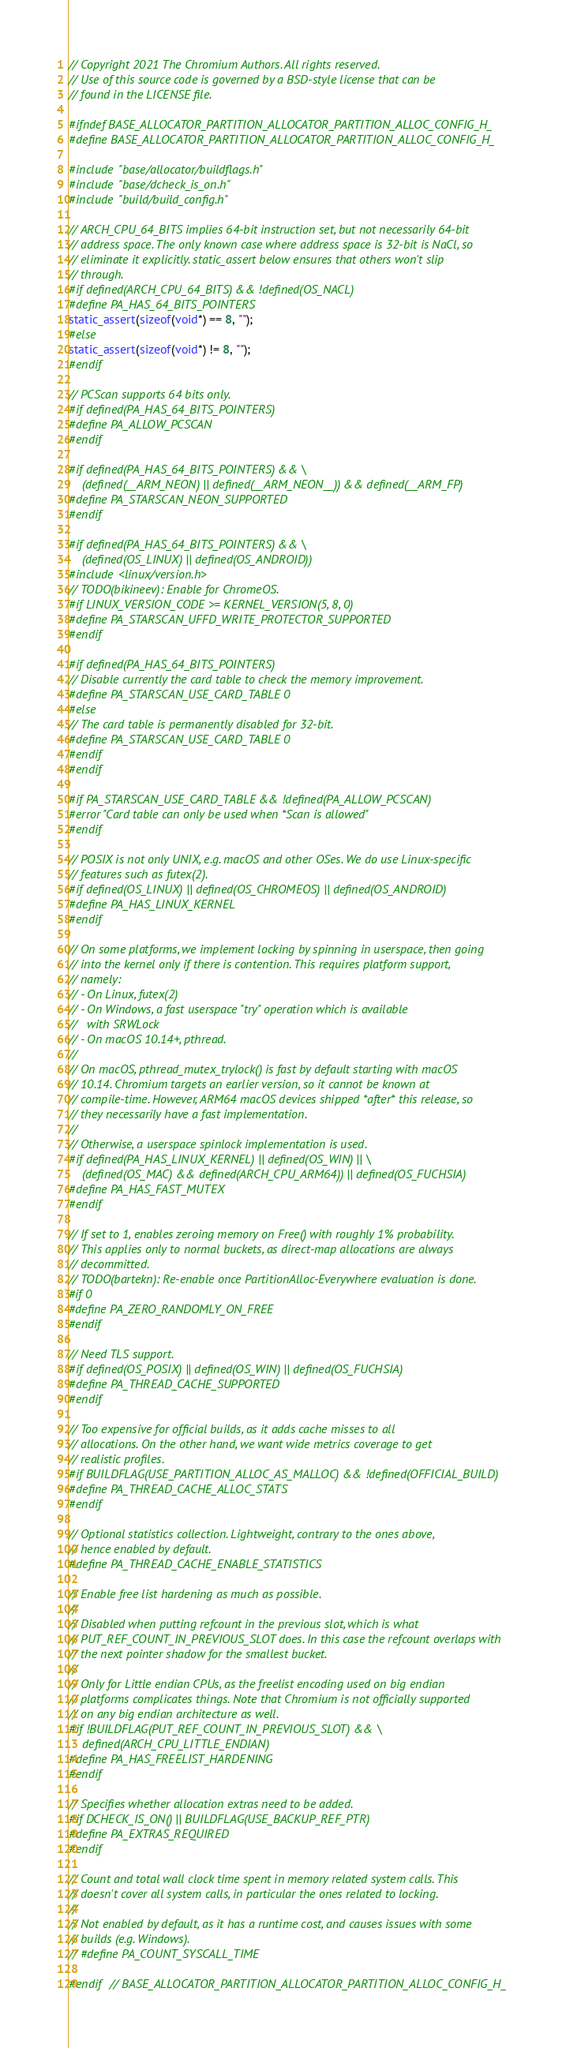<code> <loc_0><loc_0><loc_500><loc_500><_C_>// Copyright 2021 The Chromium Authors. All rights reserved.
// Use of this source code is governed by a BSD-style license that can be
// found in the LICENSE file.

#ifndef BASE_ALLOCATOR_PARTITION_ALLOCATOR_PARTITION_ALLOC_CONFIG_H_
#define BASE_ALLOCATOR_PARTITION_ALLOCATOR_PARTITION_ALLOC_CONFIG_H_

#include "base/allocator/buildflags.h"
#include "base/dcheck_is_on.h"
#include "build/build_config.h"

// ARCH_CPU_64_BITS implies 64-bit instruction set, but not necessarily 64-bit
// address space. The only known case where address space is 32-bit is NaCl, so
// eliminate it explicitly. static_assert below ensures that others won't slip
// through.
#if defined(ARCH_CPU_64_BITS) && !defined(OS_NACL)
#define PA_HAS_64_BITS_POINTERS
static_assert(sizeof(void*) == 8, "");
#else
static_assert(sizeof(void*) != 8, "");
#endif

// PCScan supports 64 bits only.
#if defined(PA_HAS_64_BITS_POINTERS)
#define PA_ALLOW_PCSCAN
#endif

#if defined(PA_HAS_64_BITS_POINTERS) && \
    (defined(__ARM_NEON) || defined(__ARM_NEON__)) && defined(__ARM_FP)
#define PA_STARSCAN_NEON_SUPPORTED
#endif

#if defined(PA_HAS_64_BITS_POINTERS) && \
    (defined(OS_LINUX) || defined(OS_ANDROID))
#include <linux/version.h>
// TODO(bikineev): Enable for ChromeOS.
#if LINUX_VERSION_CODE >= KERNEL_VERSION(5, 8, 0)
#define PA_STARSCAN_UFFD_WRITE_PROTECTOR_SUPPORTED
#endif

#if defined(PA_HAS_64_BITS_POINTERS)
// Disable currently the card table to check the memory improvement.
#define PA_STARSCAN_USE_CARD_TABLE 0
#else
// The card table is permanently disabled for 32-bit.
#define PA_STARSCAN_USE_CARD_TABLE 0
#endif
#endif

#if PA_STARSCAN_USE_CARD_TABLE && !defined(PA_ALLOW_PCSCAN)
#error "Card table can only be used when *Scan is allowed"
#endif

// POSIX is not only UNIX, e.g. macOS and other OSes. We do use Linux-specific
// features such as futex(2).
#if defined(OS_LINUX) || defined(OS_CHROMEOS) || defined(OS_ANDROID)
#define PA_HAS_LINUX_KERNEL
#endif

// On some platforms, we implement locking by spinning in userspace, then going
// into the kernel only if there is contention. This requires platform support,
// namely:
// - On Linux, futex(2)
// - On Windows, a fast userspace "try" operation which is available
//   with SRWLock
// - On macOS 10.14+, pthread.
//
// On macOS, pthread_mutex_trylock() is fast by default starting with macOS
// 10.14. Chromium targets an earlier version, so it cannot be known at
// compile-time. However, ARM64 macOS devices shipped *after* this release, so
// they necessarily have a fast implementation.
//
// Otherwise, a userspace spinlock implementation is used.
#if defined(PA_HAS_LINUX_KERNEL) || defined(OS_WIN) || \
    (defined(OS_MAC) && defined(ARCH_CPU_ARM64)) || defined(OS_FUCHSIA)
#define PA_HAS_FAST_MUTEX
#endif

// If set to 1, enables zeroing memory on Free() with roughly 1% probability.
// This applies only to normal buckets, as direct-map allocations are always
// decommitted.
// TODO(bartekn): Re-enable once PartitionAlloc-Everywhere evaluation is done.
#if 0
#define PA_ZERO_RANDOMLY_ON_FREE
#endif

// Need TLS support.
#if defined(OS_POSIX) || defined(OS_WIN) || defined(OS_FUCHSIA)
#define PA_THREAD_CACHE_SUPPORTED
#endif

// Too expensive for official builds, as it adds cache misses to all
// allocations. On the other hand, we want wide metrics coverage to get
// realistic profiles.
#if BUILDFLAG(USE_PARTITION_ALLOC_AS_MALLOC) && !defined(OFFICIAL_BUILD)
#define PA_THREAD_CACHE_ALLOC_STATS
#endif

// Optional statistics collection. Lightweight, contrary to the ones above,
// hence enabled by default.
#define PA_THREAD_CACHE_ENABLE_STATISTICS

// Enable free list hardening as much as possible.
//
// Disabled when putting refcount in the previous slot, which is what
// PUT_REF_COUNT_IN_PREVIOUS_SLOT does. In this case the refcount overlaps with
// the next pointer shadow for the smallest bucket.
//
// Only for Little endian CPUs, as the freelist encoding used on big endian
// platforms complicates things. Note that Chromium is not officially supported
// on any big endian architecture as well.
#if !BUILDFLAG(PUT_REF_COUNT_IN_PREVIOUS_SLOT) && \
    defined(ARCH_CPU_LITTLE_ENDIAN)
#define PA_HAS_FREELIST_HARDENING
#endif

// Specifies whether allocation extras need to be added.
#if DCHECK_IS_ON() || BUILDFLAG(USE_BACKUP_REF_PTR)
#define PA_EXTRAS_REQUIRED
#endif

// Count and total wall clock time spent in memory related system calls. This
// doesn't cover all system calls, in particular the ones related to locking.
//
// Not enabled by default, as it has a runtime cost, and causes issues with some
// builds (e.g. Windows).
// #define PA_COUNT_SYSCALL_TIME

#endif  // BASE_ALLOCATOR_PARTITION_ALLOCATOR_PARTITION_ALLOC_CONFIG_H_
</code> 